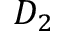Convert formula to latex. <formula><loc_0><loc_0><loc_500><loc_500>D _ { 2 }</formula> 